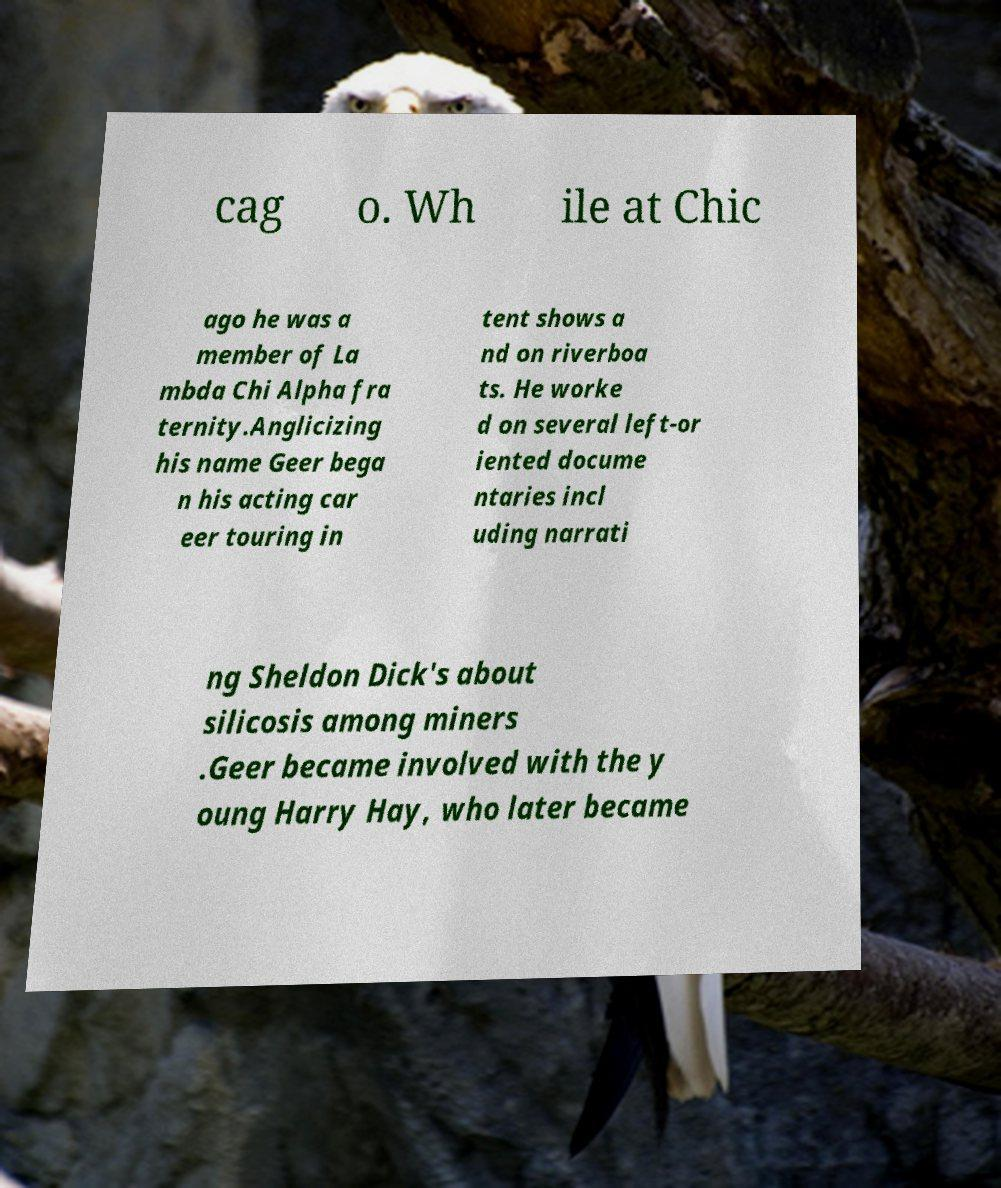I need the written content from this picture converted into text. Can you do that? cag o. Wh ile at Chic ago he was a member of La mbda Chi Alpha fra ternity.Anglicizing his name Geer bega n his acting car eer touring in tent shows a nd on riverboa ts. He worke d on several left-or iented docume ntaries incl uding narrati ng Sheldon Dick's about silicosis among miners .Geer became involved with the y oung Harry Hay, who later became 